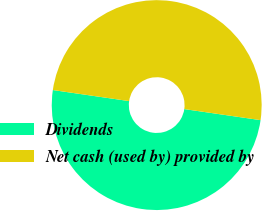Convert chart. <chart><loc_0><loc_0><loc_500><loc_500><pie_chart><fcel>Dividends<fcel>Net cash (used by) provided by<nl><fcel>50.0%<fcel>50.0%<nl></chart> 